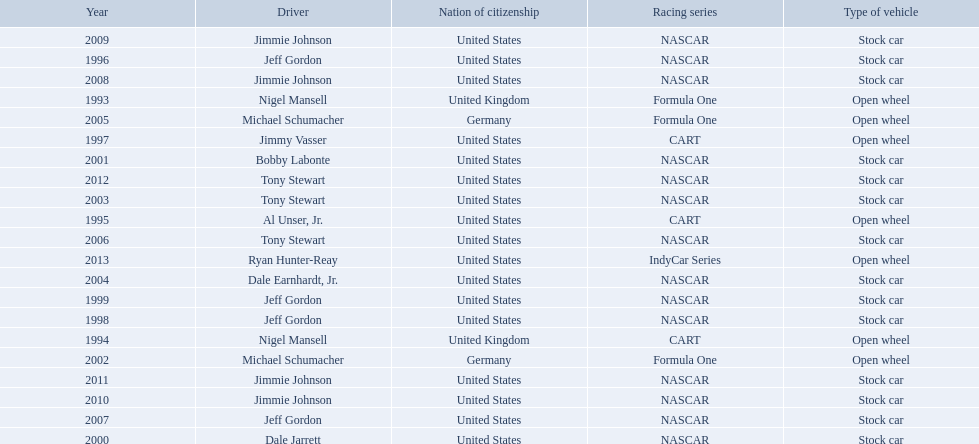What year(s) did nigel mansel receive epsy awards? 1993, 1994. What year(s) did michael schumacher receive epsy awards? 2002, 2005. What year(s) did jeff gordon receive epsy awards? 1996, 1998, 1999, 2007. What year(s) did al unser jr. receive epsy awards? 1995. Which driver only received one epsy award? Al Unser, Jr. 